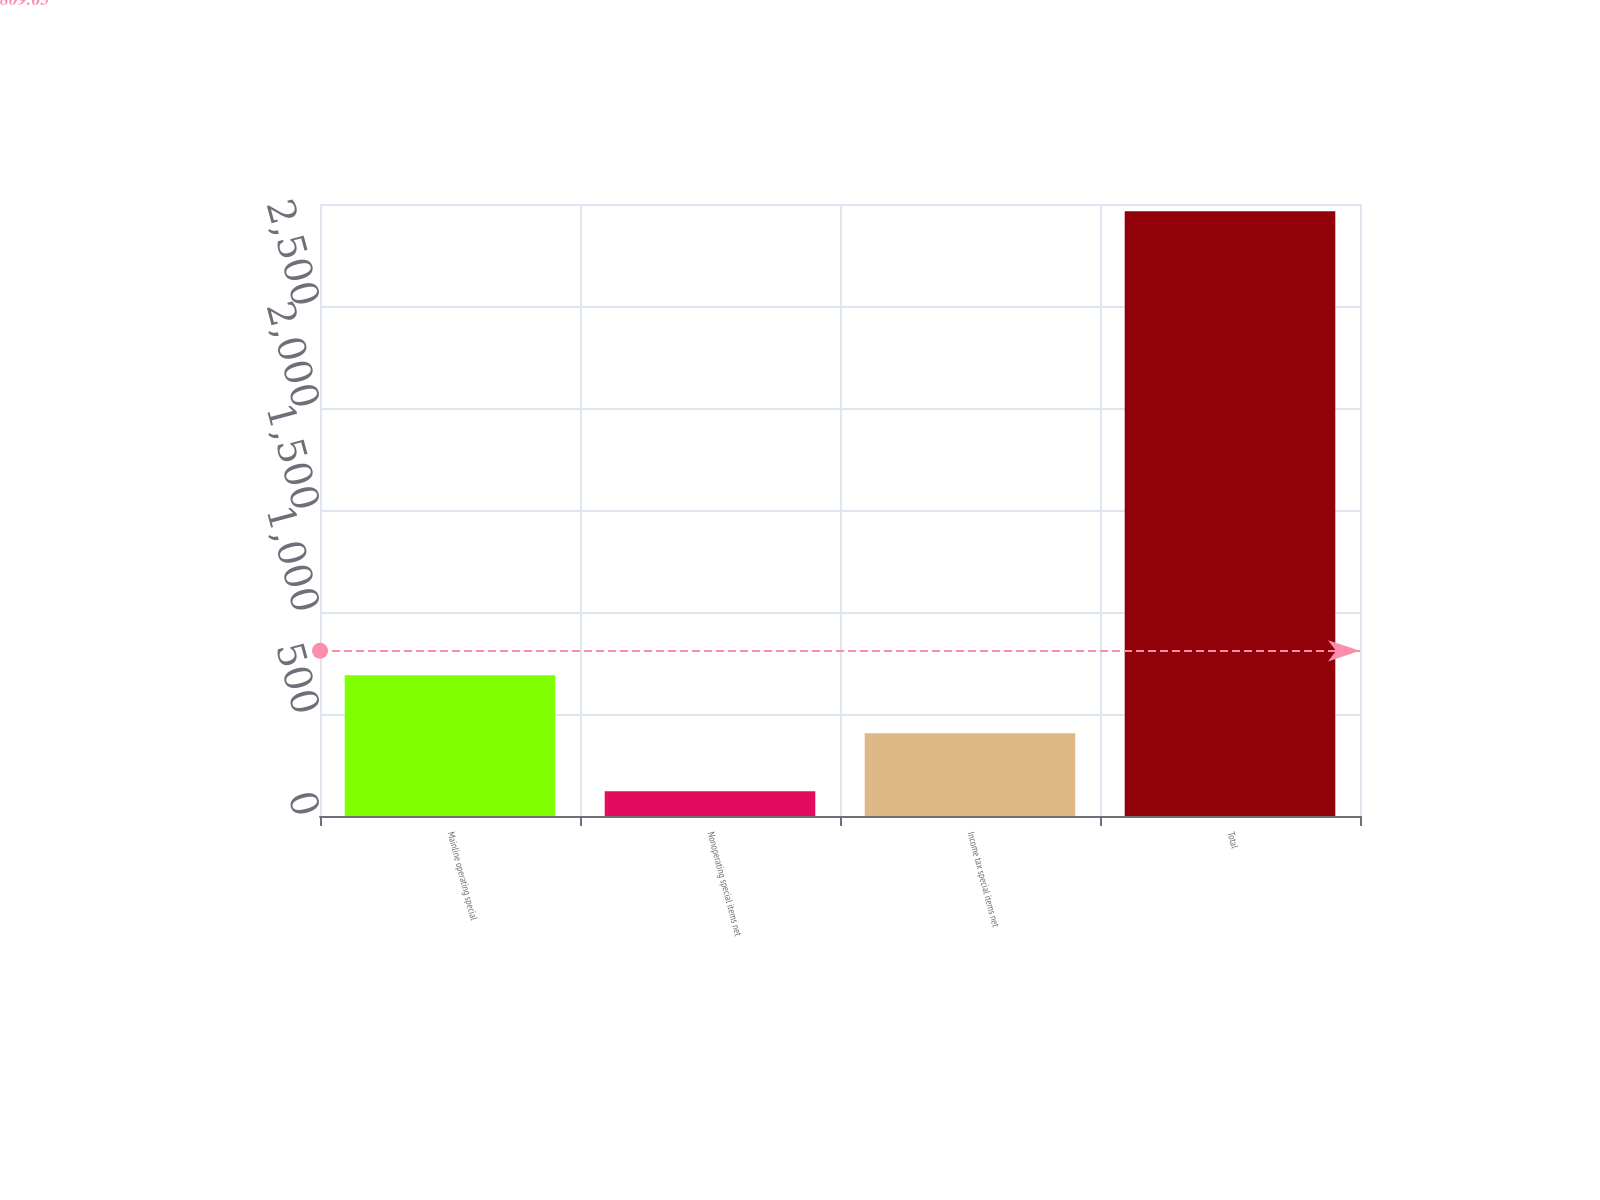<chart> <loc_0><loc_0><loc_500><loc_500><bar_chart><fcel>Mainline operating special<fcel>Nonoperating special items net<fcel>Income tax special items net<fcel>Total<nl><fcel>689.8<fcel>121<fcel>405.4<fcel>2965<nl></chart> 